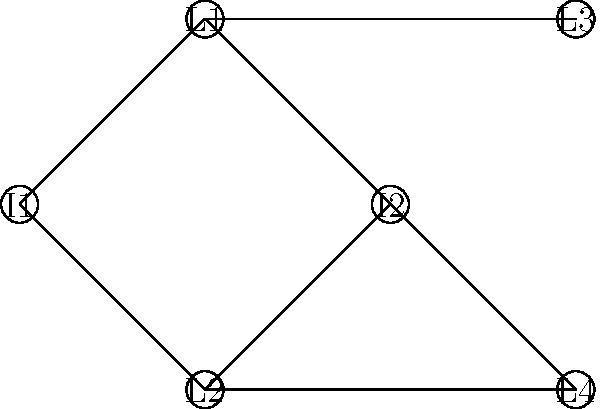In the social network graph above, nodes labeled "I" represent immigrants, and nodes labeled "L" represent local community members. What is the clustering coefficient of node I2? To calculate the clustering coefficient of node I2, we need to follow these steps:

1. Identify the neighbors of I2:
   I2 is connected to L1, L2, and L4.

2. Count the number of edges between these neighbors:
   There is 1 edge between L1 and L2.

3. Calculate the maximum possible number of edges between neighbors:
   With 3 neighbors, the maximum number of edges is $\binom{3}{2} = 3$.

4. Apply the clustering coefficient formula:
   Clustering Coefficient = $\frac{\text{Actual edges between neighbors}}{\text{Maximum possible edges between neighbors}}$

   $C_{I2} = \frac{1}{3}$

Therefore, the clustering coefficient of node I2 is $\frac{1}{3}$.
Answer: $\frac{1}{3}$ 